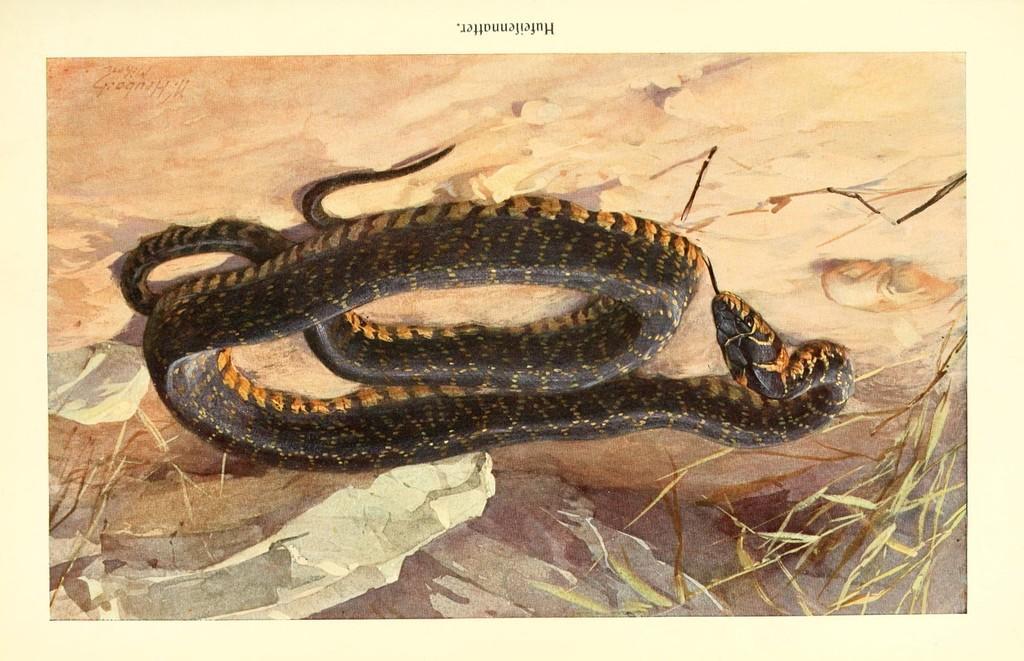In one or two sentences, can you explain what this image depicts? In this image there is a snake and there is some text which is visible and there are dry leaves. 